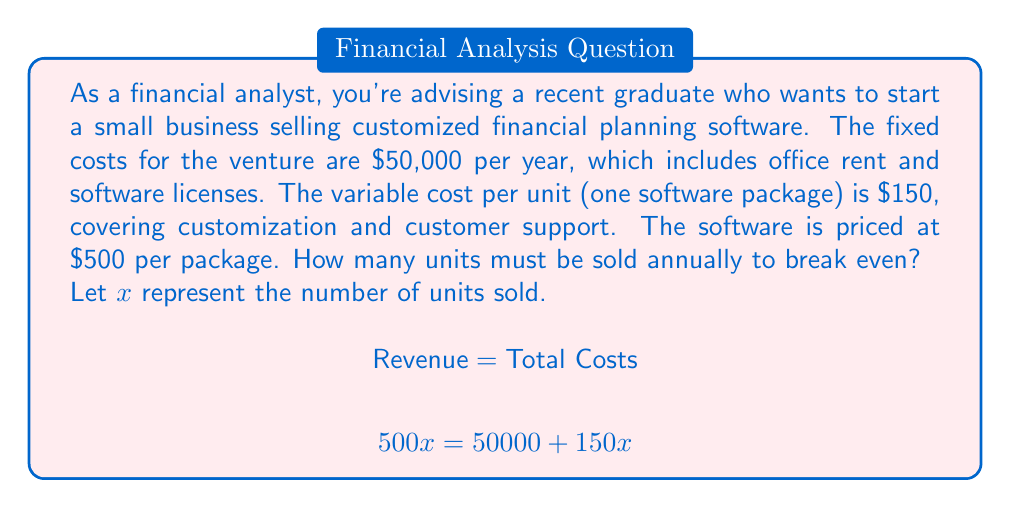What is the answer to this math problem? To solve this problem, we'll use the break-even formula:

Revenue = Fixed Costs + Variable Costs

1) First, let's define our variables:
   - Let $x$ = number of units sold
   - Fixed costs = $50,000
   - Variable cost per unit = $150
   - Price per unit = $500

2) Now, let's set up the equation:
   $$500x = 50000 + 150x$$

3) Subtract $150x$ from both sides:
   $$350x = 50000$$

4) Divide both sides by 350:
   $$x = \frac{50000}{350} = 142.86$$

5) Since we can't sell a fraction of a software package, we round up to the nearest whole number.

This means the business needs to sell 143 units to break even.

To verify:
- Revenue: $143 \times $500 = $71,500
- Total Costs: $50,000 + ($150 \times 143) = $71,450

The revenue slightly exceeds the total costs, confirming the break-even point.
Answer: The business must sell 143 units annually to break even. 